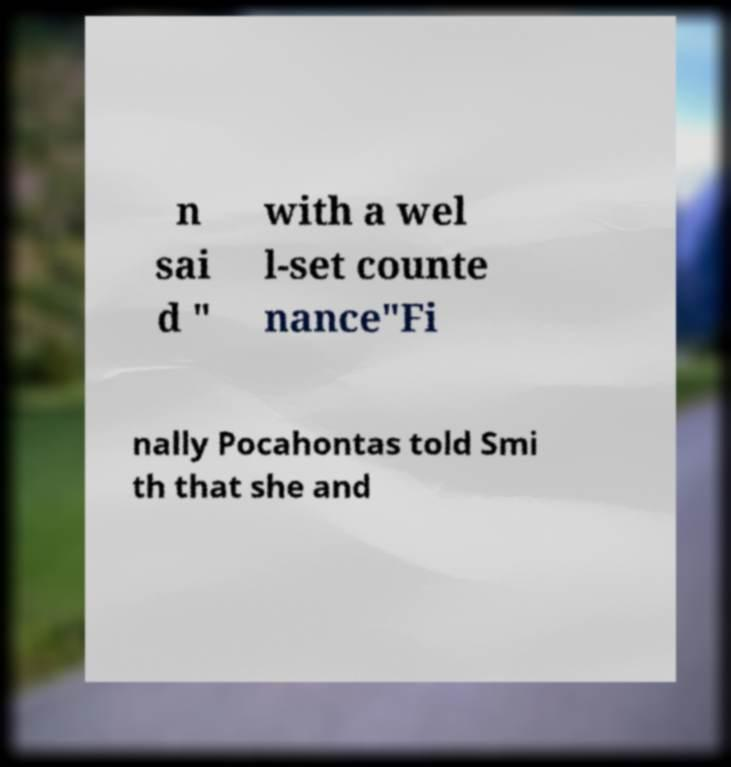There's text embedded in this image that I need extracted. Can you transcribe it verbatim? n sai d " with a wel l-set counte nance"Fi nally Pocahontas told Smi th that she and 